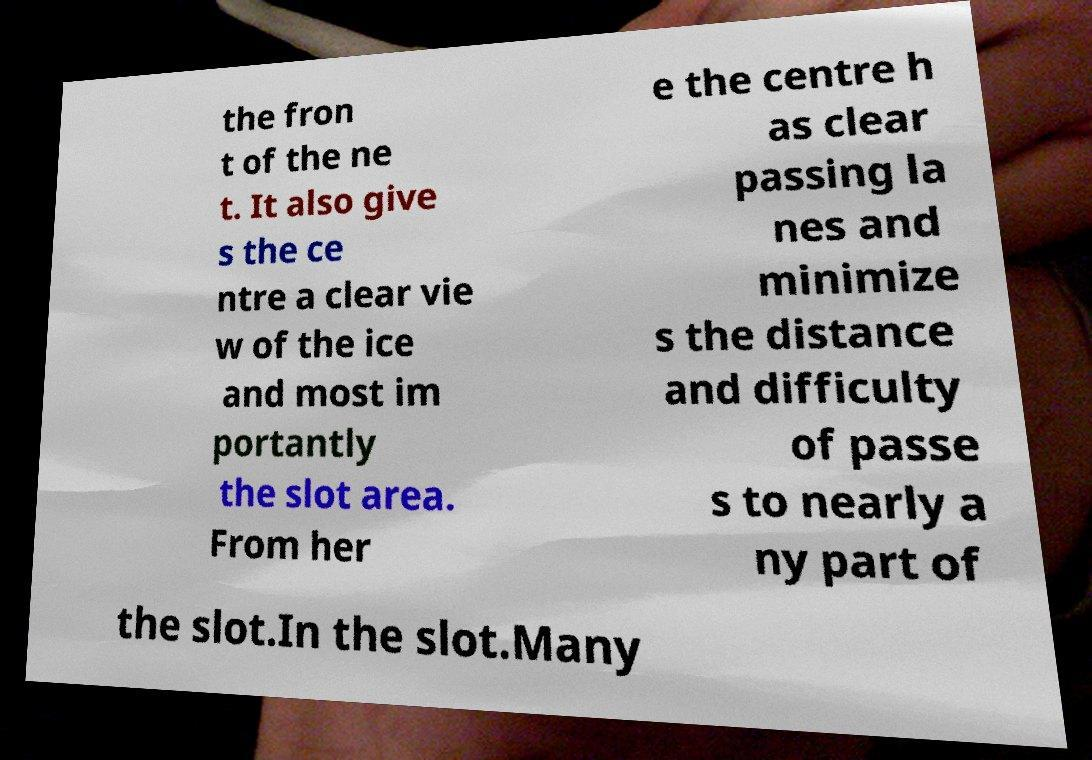There's text embedded in this image that I need extracted. Can you transcribe it verbatim? the fron t of the ne t. It also give s the ce ntre a clear vie w of the ice and most im portantly the slot area. From her e the centre h as clear passing la nes and minimize s the distance and difficulty of passe s to nearly a ny part of the slot.In the slot.Many 